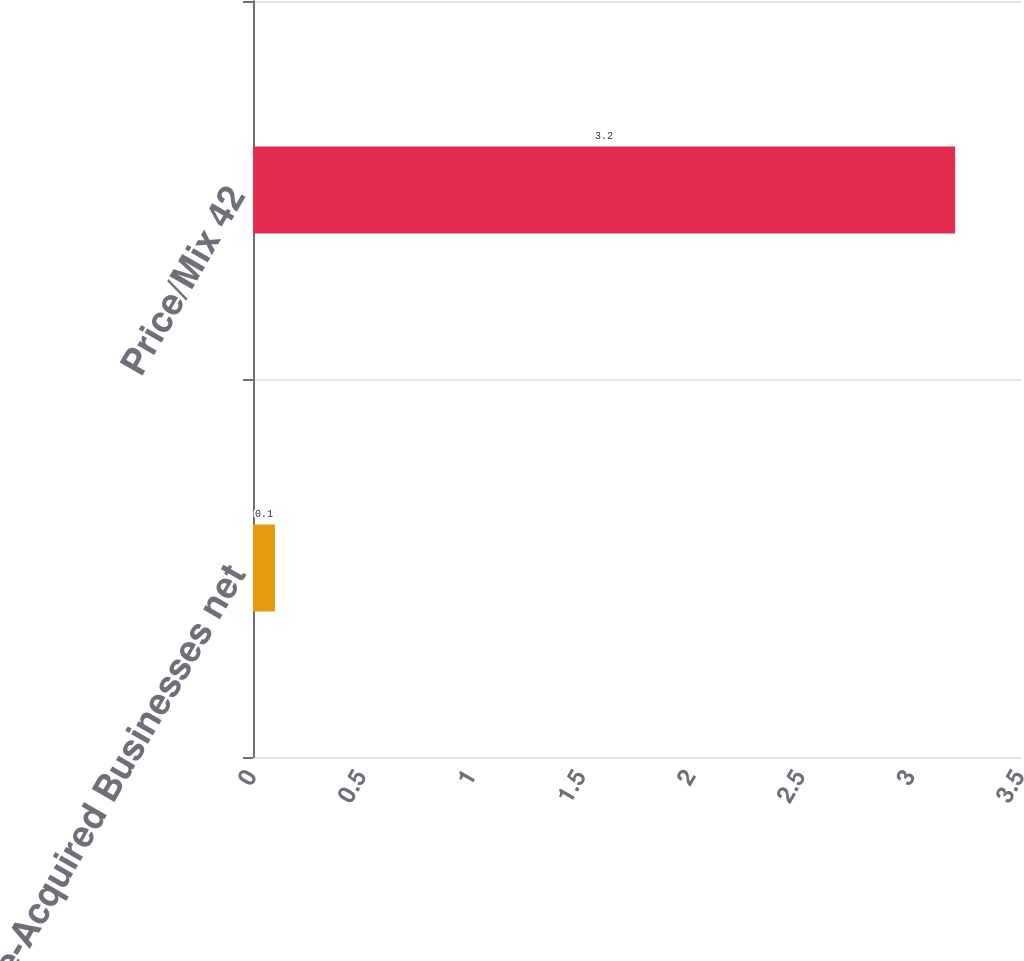<chart> <loc_0><loc_0><loc_500><loc_500><bar_chart><fcel>Volume-Acquired Businesses net<fcel>Price/Mix 42<nl><fcel>0.1<fcel>3.2<nl></chart> 